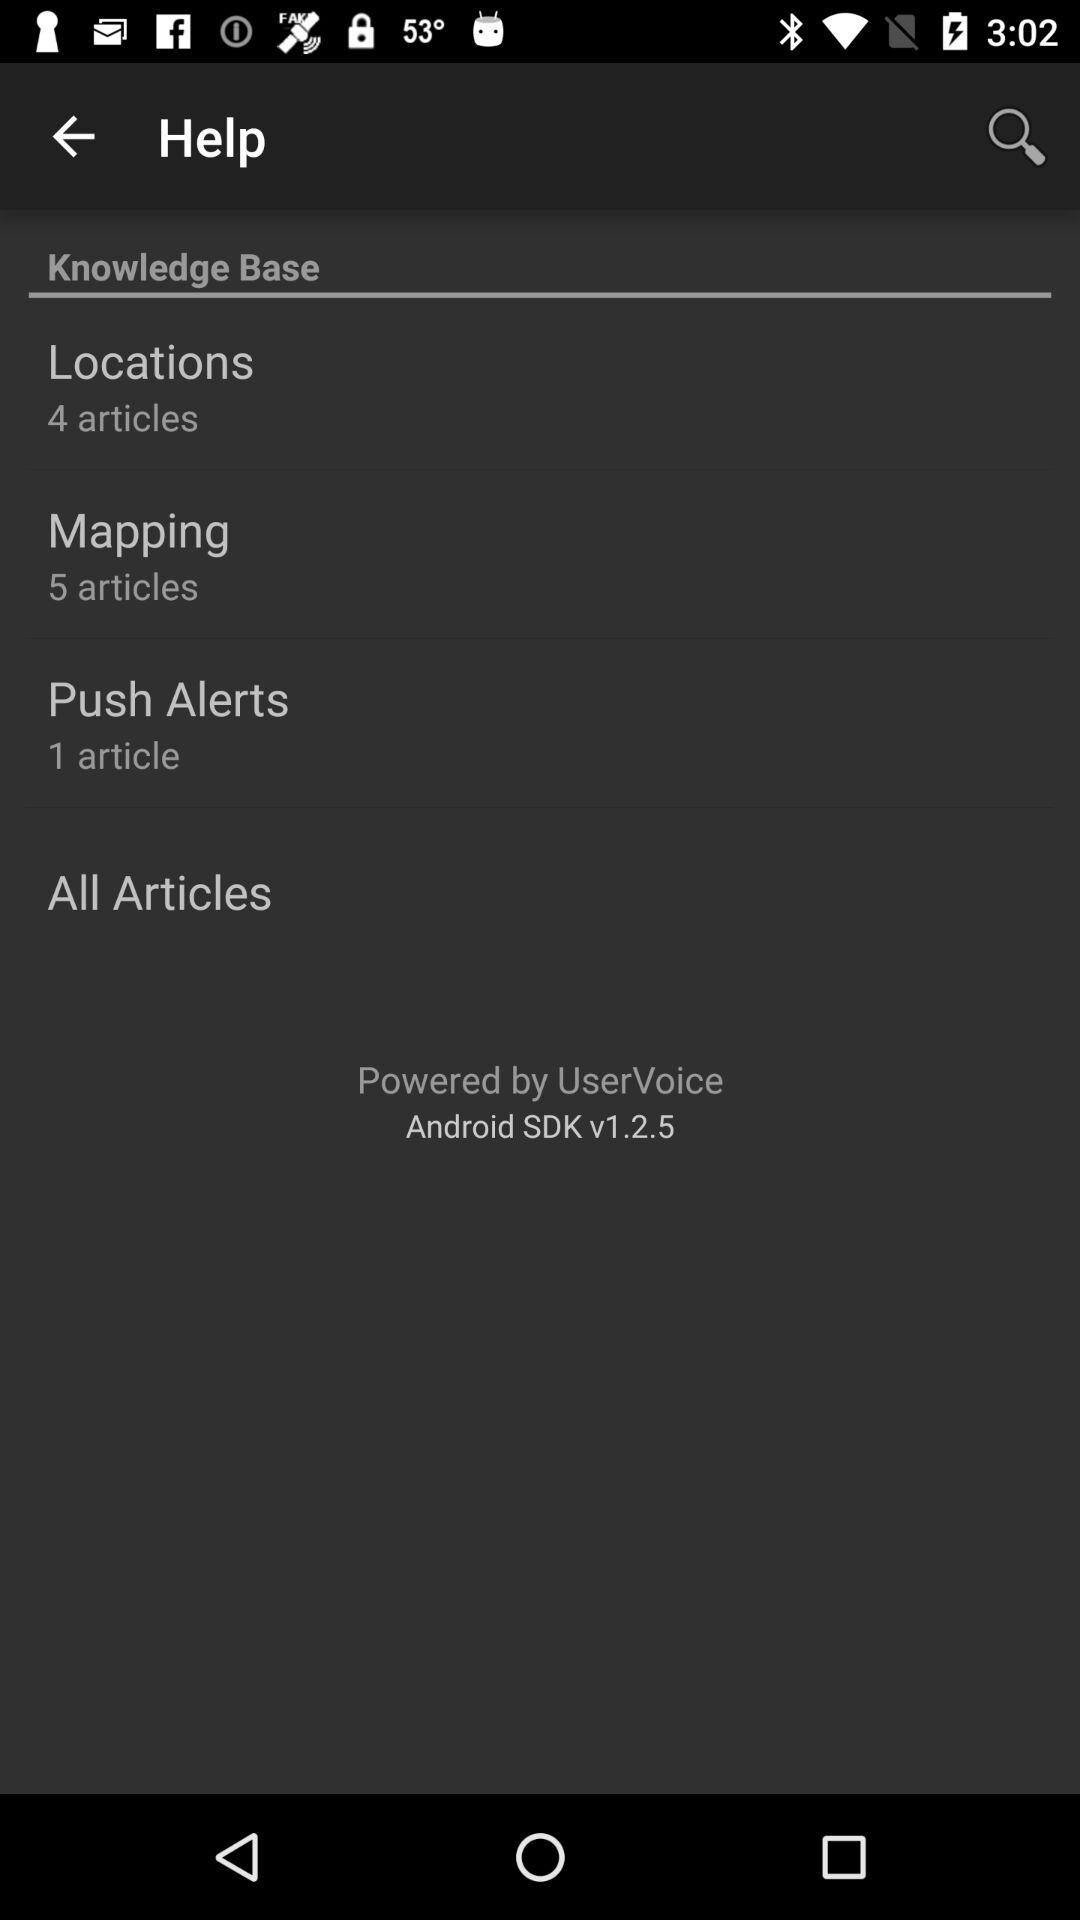What is the version? The version is 1.2.5. 